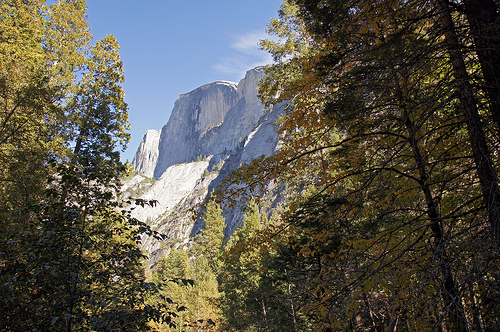<image>
Is the mountain above the tree? Yes. The mountain is positioned above the tree in the vertical space, higher up in the scene. 